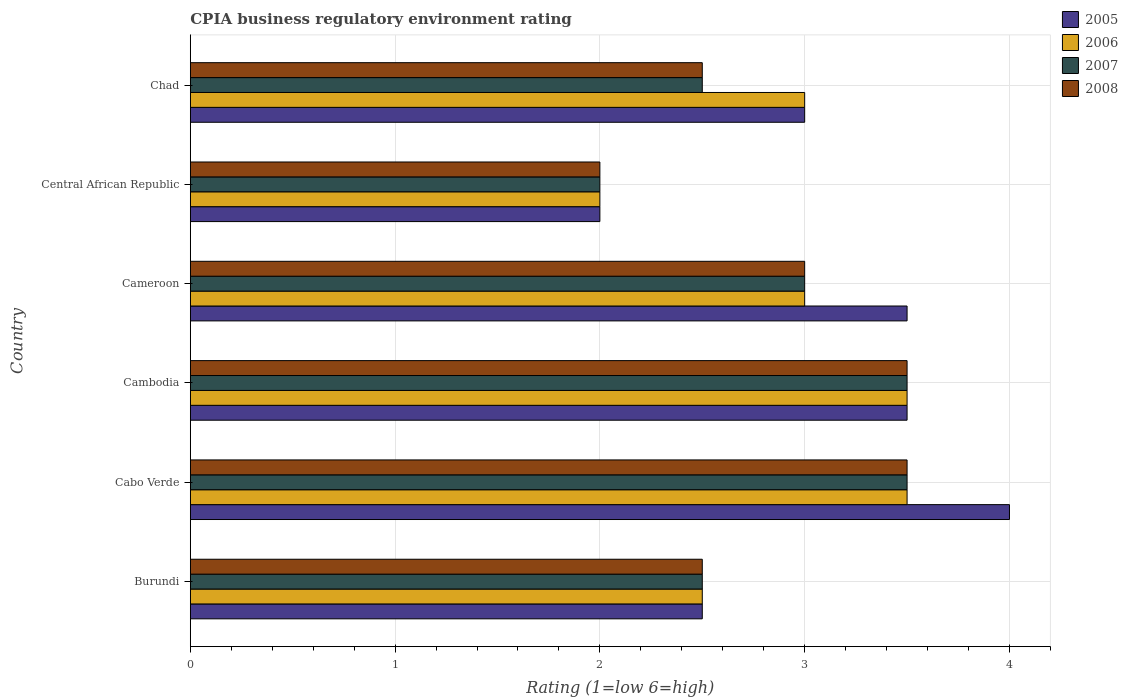How many different coloured bars are there?
Your answer should be compact. 4. Are the number of bars on each tick of the Y-axis equal?
Provide a succinct answer. Yes. How many bars are there on the 4th tick from the top?
Make the answer very short. 4. What is the label of the 4th group of bars from the top?
Provide a succinct answer. Cambodia. In how many cases, is the number of bars for a given country not equal to the number of legend labels?
Provide a succinct answer. 0. What is the CPIA rating in 2006 in Cabo Verde?
Your answer should be very brief. 3.5. In which country was the CPIA rating in 2007 maximum?
Your answer should be very brief. Cabo Verde. In which country was the CPIA rating in 2007 minimum?
Your answer should be very brief. Central African Republic. What is the difference between the CPIA rating in 2008 in Burundi and that in Central African Republic?
Your answer should be compact. 0.5. What is the average CPIA rating in 2006 per country?
Your response must be concise. 2.92. What is the difference between the CPIA rating in 2005 and CPIA rating in 2006 in Burundi?
Keep it short and to the point. 0. What is the ratio of the CPIA rating in 2005 in Cabo Verde to that in Cambodia?
Provide a succinct answer. 1.14. Is the CPIA rating in 2005 in Cabo Verde less than that in Chad?
Offer a very short reply. No. What is the difference between the highest and the second highest CPIA rating in 2006?
Your response must be concise. 0. What is the difference between the highest and the lowest CPIA rating in 2006?
Provide a succinct answer. 1.5. In how many countries, is the CPIA rating in 2007 greater than the average CPIA rating in 2007 taken over all countries?
Provide a short and direct response. 3. Is the sum of the CPIA rating in 2007 in Burundi and Cambodia greater than the maximum CPIA rating in 2005 across all countries?
Your answer should be compact. Yes. What does the 3rd bar from the top in Cameroon represents?
Keep it short and to the point. 2006. What does the 4th bar from the bottom in Cabo Verde represents?
Offer a very short reply. 2008. How many bars are there?
Your response must be concise. 24. Does the graph contain any zero values?
Your answer should be very brief. No. How many legend labels are there?
Give a very brief answer. 4. What is the title of the graph?
Ensure brevity in your answer.  CPIA business regulatory environment rating. Does "1966" appear as one of the legend labels in the graph?
Your answer should be very brief. No. What is the Rating (1=low 6=high) in 2005 in Burundi?
Offer a terse response. 2.5. What is the Rating (1=low 6=high) in 2008 in Burundi?
Your answer should be very brief. 2.5. What is the Rating (1=low 6=high) of 2007 in Cabo Verde?
Provide a short and direct response. 3.5. What is the Rating (1=low 6=high) in 2008 in Cabo Verde?
Your answer should be compact. 3.5. What is the Rating (1=low 6=high) in 2005 in Cambodia?
Ensure brevity in your answer.  3.5. What is the Rating (1=low 6=high) in 2005 in Central African Republic?
Make the answer very short. 2. What is the Rating (1=low 6=high) of 2006 in Central African Republic?
Keep it short and to the point. 2. What is the Rating (1=low 6=high) of 2008 in Central African Republic?
Provide a short and direct response. 2. What is the Rating (1=low 6=high) of 2006 in Chad?
Keep it short and to the point. 3. What is the Rating (1=low 6=high) in 2008 in Chad?
Provide a succinct answer. 2.5. Across all countries, what is the maximum Rating (1=low 6=high) of 2006?
Your answer should be very brief. 3.5. Across all countries, what is the minimum Rating (1=low 6=high) in 2005?
Provide a short and direct response. 2. Across all countries, what is the minimum Rating (1=low 6=high) in 2008?
Your response must be concise. 2. What is the total Rating (1=low 6=high) in 2006 in the graph?
Provide a short and direct response. 17.5. What is the total Rating (1=low 6=high) in 2008 in the graph?
Your answer should be compact. 17. What is the difference between the Rating (1=low 6=high) in 2005 in Burundi and that in Cabo Verde?
Give a very brief answer. -1.5. What is the difference between the Rating (1=low 6=high) in 2006 in Burundi and that in Cabo Verde?
Provide a short and direct response. -1. What is the difference between the Rating (1=low 6=high) in 2007 in Burundi and that in Cabo Verde?
Your answer should be compact. -1. What is the difference between the Rating (1=low 6=high) in 2008 in Burundi and that in Cabo Verde?
Make the answer very short. -1. What is the difference between the Rating (1=low 6=high) of 2005 in Burundi and that in Cambodia?
Offer a terse response. -1. What is the difference between the Rating (1=low 6=high) of 2005 in Burundi and that in Cameroon?
Offer a very short reply. -1. What is the difference between the Rating (1=low 6=high) in 2007 in Burundi and that in Central African Republic?
Provide a short and direct response. 0.5. What is the difference between the Rating (1=low 6=high) of 2008 in Burundi and that in Central African Republic?
Offer a very short reply. 0.5. What is the difference between the Rating (1=low 6=high) in 2005 in Burundi and that in Chad?
Your answer should be compact. -0.5. What is the difference between the Rating (1=low 6=high) of 2007 in Burundi and that in Chad?
Your answer should be very brief. 0. What is the difference between the Rating (1=low 6=high) in 2008 in Burundi and that in Chad?
Ensure brevity in your answer.  0. What is the difference between the Rating (1=low 6=high) in 2006 in Cabo Verde and that in Cambodia?
Your answer should be very brief. 0. What is the difference between the Rating (1=low 6=high) in 2008 in Cabo Verde and that in Cambodia?
Provide a short and direct response. 0. What is the difference between the Rating (1=low 6=high) of 2006 in Cabo Verde and that in Cameroon?
Offer a terse response. 0.5. What is the difference between the Rating (1=low 6=high) of 2006 in Cabo Verde and that in Central African Republic?
Your response must be concise. 1.5. What is the difference between the Rating (1=low 6=high) in 2006 in Cabo Verde and that in Chad?
Give a very brief answer. 0.5. What is the difference between the Rating (1=low 6=high) in 2007 in Cabo Verde and that in Chad?
Your answer should be very brief. 1. What is the difference between the Rating (1=low 6=high) of 2008 in Cabo Verde and that in Chad?
Offer a very short reply. 1. What is the difference between the Rating (1=low 6=high) in 2005 in Cambodia and that in Cameroon?
Keep it short and to the point. 0. What is the difference between the Rating (1=low 6=high) of 2006 in Cambodia and that in Cameroon?
Give a very brief answer. 0.5. What is the difference between the Rating (1=low 6=high) of 2007 in Cambodia and that in Central African Republic?
Keep it short and to the point. 1.5. What is the difference between the Rating (1=low 6=high) in 2008 in Cambodia and that in Central African Republic?
Provide a short and direct response. 1.5. What is the difference between the Rating (1=low 6=high) of 2005 in Cambodia and that in Chad?
Offer a terse response. 0.5. What is the difference between the Rating (1=low 6=high) in 2007 in Cambodia and that in Chad?
Offer a very short reply. 1. What is the difference between the Rating (1=low 6=high) in 2007 in Cameroon and that in Chad?
Give a very brief answer. 0.5. What is the difference between the Rating (1=low 6=high) in 2008 in Cameroon and that in Chad?
Make the answer very short. 0.5. What is the difference between the Rating (1=low 6=high) of 2006 in Central African Republic and that in Chad?
Keep it short and to the point. -1. What is the difference between the Rating (1=low 6=high) in 2007 in Central African Republic and that in Chad?
Keep it short and to the point. -0.5. What is the difference between the Rating (1=low 6=high) of 2005 in Burundi and the Rating (1=low 6=high) of 2006 in Cabo Verde?
Give a very brief answer. -1. What is the difference between the Rating (1=low 6=high) in 2006 in Burundi and the Rating (1=low 6=high) in 2008 in Cabo Verde?
Offer a very short reply. -1. What is the difference between the Rating (1=low 6=high) of 2005 in Burundi and the Rating (1=low 6=high) of 2007 in Cambodia?
Your answer should be compact. -1. What is the difference between the Rating (1=low 6=high) in 2006 in Burundi and the Rating (1=low 6=high) in 2007 in Cambodia?
Your response must be concise. -1. What is the difference between the Rating (1=low 6=high) in 2007 in Burundi and the Rating (1=low 6=high) in 2008 in Cambodia?
Your answer should be very brief. -1. What is the difference between the Rating (1=low 6=high) in 2005 in Burundi and the Rating (1=low 6=high) in 2006 in Cameroon?
Provide a short and direct response. -0.5. What is the difference between the Rating (1=low 6=high) of 2005 in Burundi and the Rating (1=low 6=high) of 2007 in Cameroon?
Give a very brief answer. -0.5. What is the difference between the Rating (1=low 6=high) of 2006 in Burundi and the Rating (1=low 6=high) of 2007 in Cameroon?
Your answer should be very brief. -0.5. What is the difference between the Rating (1=low 6=high) of 2007 in Burundi and the Rating (1=low 6=high) of 2008 in Cameroon?
Give a very brief answer. -0.5. What is the difference between the Rating (1=low 6=high) in 2005 in Burundi and the Rating (1=low 6=high) in 2006 in Central African Republic?
Provide a short and direct response. 0.5. What is the difference between the Rating (1=low 6=high) of 2005 in Burundi and the Rating (1=low 6=high) of 2008 in Central African Republic?
Provide a succinct answer. 0.5. What is the difference between the Rating (1=low 6=high) of 2006 in Burundi and the Rating (1=low 6=high) of 2008 in Central African Republic?
Your response must be concise. 0.5. What is the difference between the Rating (1=low 6=high) in 2005 in Burundi and the Rating (1=low 6=high) in 2007 in Chad?
Your answer should be compact. 0. What is the difference between the Rating (1=low 6=high) of 2005 in Burundi and the Rating (1=low 6=high) of 2008 in Chad?
Your answer should be compact. 0. What is the difference between the Rating (1=low 6=high) of 2006 in Burundi and the Rating (1=low 6=high) of 2007 in Chad?
Your response must be concise. 0. What is the difference between the Rating (1=low 6=high) in 2006 in Burundi and the Rating (1=low 6=high) in 2008 in Chad?
Provide a succinct answer. 0. What is the difference between the Rating (1=low 6=high) in 2005 in Cabo Verde and the Rating (1=low 6=high) in 2006 in Cambodia?
Keep it short and to the point. 0.5. What is the difference between the Rating (1=low 6=high) of 2005 in Cabo Verde and the Rating (1=low 6=high) of 2007 in Cambodia?
Give a very brief answer. 0.5. What is the difference between the Rating (1=low 6=high) in 2006 in Cabo Verde and the Rating (1=low 6=high) in 2007 in Cambodia?
Your answer should be compact. 0. What is the difference between the Rating (1=low 6=high) of 2007 in Cabo Verde and the Rating (1=low 6=high) of 2008 in Cambodia?
Your answer should be very brief. 0. What is the difference between the Rating (1=low 6=high) in 2005 in Cabo Verde and the Rating (1=low 6=high) in 2006 in Cameroon?
Offer a very short reply. 1. What is the difference between the Rating (1=low 6=high) of 2005 in Cabo Verde and the Rating (1=low 6=high) of 2007 in Cameroon?
Offer a terse response. 1. What is the difference between the Rating (1=low 6=high) of 2005 in Cabo Verde and the Rating (1=low 6=high) of 2008 in Cameroon?
Your answer should be very brief. 1. What is the difference between the Rating (1=low 6=high) in 2006 in Cabo Verde and the Rating (1=low 6=high) in 2008 in Cameroon?
Ensure brevity in your answer.  0.5. What is the difference between the Rating (1=low 6=high) of 2005 in Cabo Verde and the Rating (1=low 6=high) of 2007 in Central African Republic?
Offer a very short reply. 2. What is the difference between the Rating (1=low 6=high) in 2006 in Cabo Verde and the Rating (1=low 6=high) in 2007 in Central African Republic?
Offer a terse response. 1.5. What is the difference between the Rating (1=low 6=high) of 2005 in Cabo Verde and the Rating (1=low 6=high) of 2006 in Chad?
Give a very brief answer. 1. What is the difference between the Rating (1=low 6=high) in 2005 in Cambodia and the Rating (1=low 6=high) in 2006 in Cameroon?
Make the answer very short. 0.5. What is the difference between the Rating (1=low 6=high) in 2005 in Cambodia and the Rating (1=low 6=high) in 2007 in Cameroon?
Make the answer very short. 0.5. What is the difference between the Rating (1=low 6=high) of 2005 in Cambodia and the Rating (1=low 6=high) of 2008 in Cameroon?
Offer a terse response. 0.5. What is the difference between the Rating (1=low 6=high) of 2006 in Cambodia and the Rating (1=low 6=high) of 2008 in Cameroon?
Your answer should be compact. 0.5. What is the difference between the Rating (1=low 6=high) of 2005 in Cambodia and the Rating (1=low 6=high) of 2006 in Central African Republic?
Provide a succinct answer. 1.5. What is the difference between the Rating (1=low 6=high) in 2007 in Cambodia and the Rating (1=low 6=high) in 2008 in Central African Republic?
Ensure brevity in your answer.  1.5. What is the difference between the Rating (1=low 6=high) in 2005 in Cambodia and the Rating (1=low 6=high) in 2008 in Chad?
Give a very brief answer. 1. What is the difference between the Rating (1=low 6=high) in 2006 in Cambodia and the Rating (1=low 6=high) in 2008 in Chad?
Provide a short and direct response. 1. What is the difference between the Rating (1=low 6=high) in 2007 in Cambodia and the Rating (1=low 6=high) in 2008 in Chad?
Keep it short and to the point. 1. What is the difference between the Rating (1=low 6=high) in 2005 in Cameroon and the Rating (1=low 6=high) in 2007 in Central African Republic?
Give a very brief answer. 1.5. What is the difference between the Rating (1=low 6=high) of 2006 in Cameroon and the Rating (1=low 6=high) of 2008 in Central African Republic?
Provide a short and direct response. 1. What is the difference between the Rating (1=low 6=high) in 2007 in Cameroon and the Rating (1=low 6=high) in 2008 in Central African Republic?
Offer a terse response. 1. What is the difference between the Rating (1=low 6=high) of 2005 in Cameroon and the Rating (1=low 6=high) of 2007 in Chad?
Your answer should be very brief. 1. What is the difference between the Rating (1=low 6=high) of 2005 in Cameroon and the Rating (1=low 6=high) of 2008 in Chad?
Your answer should be very brief. 1. What is the difference between the Rating (1=low 6=high) of 2006 in Cameroon and the Rating (1=low 6=high) of 2007 in Chad?
Provide a succinct answer. 0.5. What is the difference between the Rating (1=low 6=high) in 2007 in Cameroon and the Rating (1=low 6=high) in 2008 in Chad?
Keep it short and to the point. 0.5. What is the difference between the Rating (1=low 6=high) of 2005 in Central African Republic and the Rating (1=low 6=high) of 2006 in Chad?
Make the answer very short. -1. What is the difference between the Rating (1=low 6=high) of 2005 in Central African Republic and the Rating (1=low 6=high) of 2007 in Chad?
Give a very brief answer. -0.5. What is the difference between the Rating (1=low 6=high) in 2005 in Central African Republic and the Rating (1=low 6=high) in 2008 in Chad?
Your answer should be compact. -0.5. What is the average Rating (1=low 6=high) of 2005 per country?
Give a very brief answer. 3.08. What is the average Rating (1=low 6=high) in 2006 per country?
Offer a terse response. 2.92. What is the average Rating (1=low 6=high) of 2007 per country?
Your response must be concise. 2.83. What is the average Rating (1=low 6=high) of 2008 per country?
Your response must be concise. 2.83. What is the difference between the Rating (1=low 6=high) of 2005 and Rating (1=low 6=high) of 2008 in Burundi?
Give a very brief answer. 0. What is the difference between the Rating (1=low 6=high) in 2006 and Rating (1=low 6=high) in 2007 in Burundi?
Your answer should be compact. 0. What is the difference between the Rating (1=low 6=high) in 2006 and Rating (1=low 6=high) in 2008 in Burundi?
Make the answer very short. 0. What is the difference between the Rating (1=low 6=high) in 2007 and Rating (1=low 6=high) in 2008 in Burundi?
Provide a short and direct response. 0. What is the difference between the Rating (1=low 6=high) in 2005 and Rating (1=low 6=high) in 2006 in Cabo Verde?
Your response must be concise. 0.5. What is the difference between the Rating (1=low 6=high) of 2005 and Rating (1=low 6=high) of 2007 in Cabo Verde?
Provide a succinct answer. 0.5. What is the difference between the Rating (1=low 6=high) in 2005 and Rating (1=low 6=high) in 2008 in Cabo Verde?
Provide a succinct answer. 0.5. What is the difference between the Rating (1=low 6=high) in 2007 and Rating (1=low 6=high) in 2008 in Cabo Verde?
Keep it short and to the point. 0. What is the difference between the Rating (1=low 6=high) of 2005 and Rating (1=low 6=high) of 2006 in Cambodia?
Offer a very short reply. 0. What is the difference between the Rating (1=low 6=high) in 2005 and Rating (1=low 6=high) in 2007 in Cambodia?
Offer a terse response. 0. What is the difference between the Rating (1=low 6=high) in 2007 and Rating (1=low 6=high) in 2008 in Cambodia?
Provide a succinct answer. 0. What is the difference between the Rating (1=low 6=high) of 2006 and Rating (1=low 6=high) of 2007 in Cameroon?
Offer a very short reply. 0. What is the difference between the Rating (1=low 6=high) of 2005 and Rating (1=low 6=high) of 2006 in Central African Republic?
Your answer should be very brief. 0. What is the difference between the Rating (1=low 6=high) of 2006 and Rating (1=low 6=high) of 2007 in Central African Republic?
Make the answer very short. 0. What is the difference between the Rating (1=low 6=high) in 2005 and Rating (1=low 6=high) in 2006 in Chad?
Ensure brevity in your answer.  0. What is the difference between the Rating (1=low 6=high) in 2005 and Rating (1=low 6=high) in 2007 in Chad?
Your answer should be very brief. 0.5. What is the difference between the Rating (1=low 6=high) of 2005 and Rating (1=low 6=high) of 2008 in Chad?
Your answer should be compact. 0.5. What is the difference between the Rating (1=low 6=high) of 2007 and Rating (1=low 6=high) of 2008 in Chad?
Offer a very short reply. 0. What is the ratio of the Rating (1=low 6=high) of 2005 in Burundi to that in Cameroon?
Offer a terse response. 0.71. What is the ratio of the Rating (1=low 6=high) of 2006 in Burundi to that in Cameroon?
Ensure brevity in your answer.  0.83. What is the ratio of the Rating (1=low 6=high) of 2008 in Burundi to that in Cameroon?
Your answer should be very brief. 0.83. What is the ratio of the Rating (1=low 6=high) of 2005 in Burundi to that in Central African Republic?
Offer a very short reply. 1.25. What is the ratio of the Rating (1=low 6=high) of 2006 in Burundi to that in Central African Republic?
Your answer should be compact. 1.25. What is the ratio of the Rating (1=low 6=high) in 2005 in Burundi to that in Chad?
Keep it short and to the point. 0.83. What is the ratio of the Rating (1=low 6=high) in 2006 in Burundi to that in Chad?
Provide a succinct answer. 0.83. What is the ratio of the Rating (1=low 6=high) in 2007 in Burundi to that in Chad?
Provide a succinct answer. 1. What is the ratio of the Rating (1=low 6=high) in 2008 in Burundi to that in Chad?
Your response must be concise. 1. What is the ratio of the Rating (1=low 6=high) of 2005 in Cabo Verde to that in Cambodia?
Provide a short and direct response. 1.14. What is the ratio of the Rating (1=low 6=high) of 2006 in Cabo Verde to that in Cambodia?
Your answer should be very brief. 1. What is the ratio of the Rating (1=low 6=high) in 2007 in Cabo Verde to that in Cambodia?
Your answer should be compact. 1. What is the ratio of the Rating (1=low 6=high) in 2008 in Cabo Verde to that in Cambodia?
Keep it short and to the point. 1. What is the ratio of the Rating (1=low 6=high) of 2006 in Cabo Verde to that in Cameroon?
Your answer should be very brief. 1.17. What is the ratio of the Rating (1=low 6=high) in 2008 in Cabo Verde to that in Cameroon?
Offer a very short reply. 1.17. What is the ratio of the Rating (1=low 6=high) of 2005 in Cabo Verde to that in Central African Republic?
Offer a very short reply. 2. What is the ratio of the Rating (1=low 6=high) of 2006 in Cabo Verde to that in Central African Republic?
Keep it short and to the point. 1.75. What is the ratio of the Rating (1=low 6=high) in 2005 in Cabo Verde to that in Chad?
Offer a terse response. 1.33. What is the ratio of the Rating (1=low 6=high) of 2008 in Cabo Verde to that in Chad?
Your response must be concise. 1.4. What is the ratio of the Rating (1=low 6=high) in 2006 in Cambodia to that in Central African Republic?
Your answer should be very brief. 1.75. What is the ratio of the Rating (1=low 6=high) in 2007 in Cambodia to that in Central African Republic?
Provide a succinct answer. 1.75. What is the ratio of the Rating (1=low 6=high) of 2005 in Cambodia to that in Chad?
Your response must be concise. 1.17. What is the ratio of the Rating (1=low 6=high) in 2006 in Cambodia to that in Chad?
Offer a very short reply. 1.17. What is the ratio of the Rating (1=low 6=high) in 2007 in Cameroon to that in Central African Republic?
Make the answer very short. 1.5. What is the ratio of the Rating (1=low 6=high) of 2008 in Cameroon to that in Central African Republic?
Your answer should be compact. 1.5. What is the ratio of the Rating (1=low 6=high) of 2005 in Cameroon to that in Chad?
Make the answer very short. 1.17. What is the ratio of the Rating (1=low 6=high) in 2006 in Cameroon to that in Chad?
Provide a succinct answer. 1. What is the ratio of the Rating (1=low 6=high) of 2008 in Cameroon to that in Chad?
Make the answer very short. 1.2. What is the ratio of the Rating (1=low 6=high) of 2005 in Central African Republic to that in Chad?
Provide a succinct answer. 0.67. What is the ratio of the Rating (1=low 6=high) in 2007 in Central African Republic to that in Chad?
Make the answer very short. 0.8. What is the difference between the highest and the second highest Rating (1=low 6=high) in 2007?
Offer a very short reply. 0. What is the difference between the highest and the lowest Rating (1=low 6=high) of 2005?
Ensure brevity in your answer.  2. What is the difference between the highest and the lowest Rating (1=low 6=high) in 2006?
Give a very brief answer. 1.5. What is the difference between the highest and the lowest Rating (1=low 6=high) in 2007?
Give a very brief answer. 1.5. What is the difference between the highest and the lowest Rating (1=low 6=high) in 2008?
Make the answer very short. 1.5. 